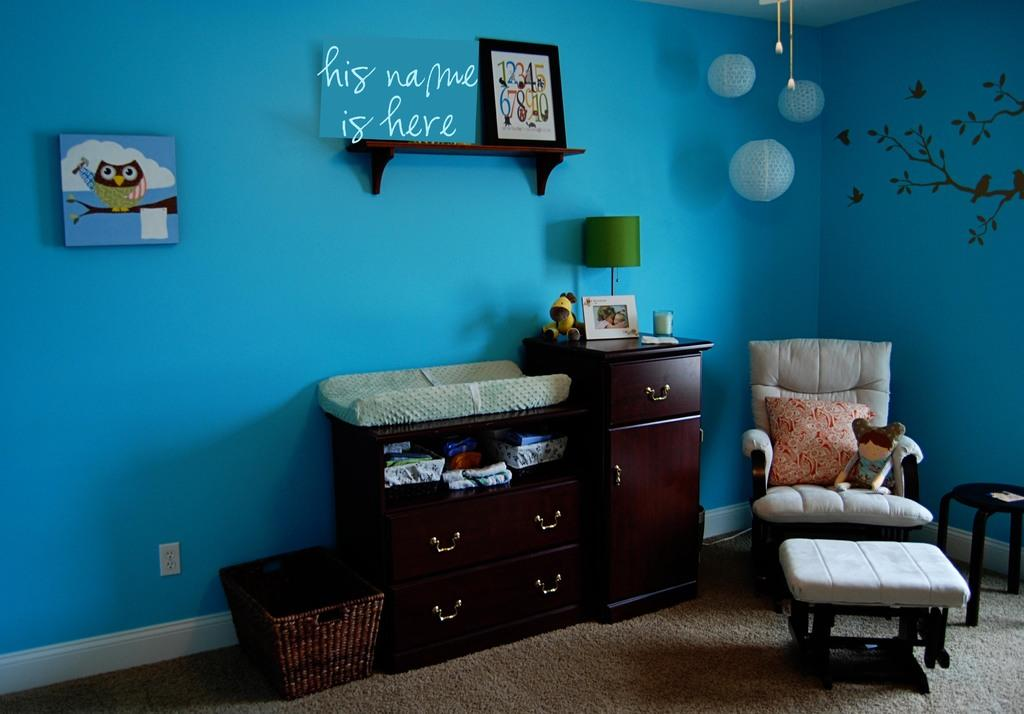<image>
Offer a succinct explanation of the picture presented. A blue room with the words "his name is here" on the wall 